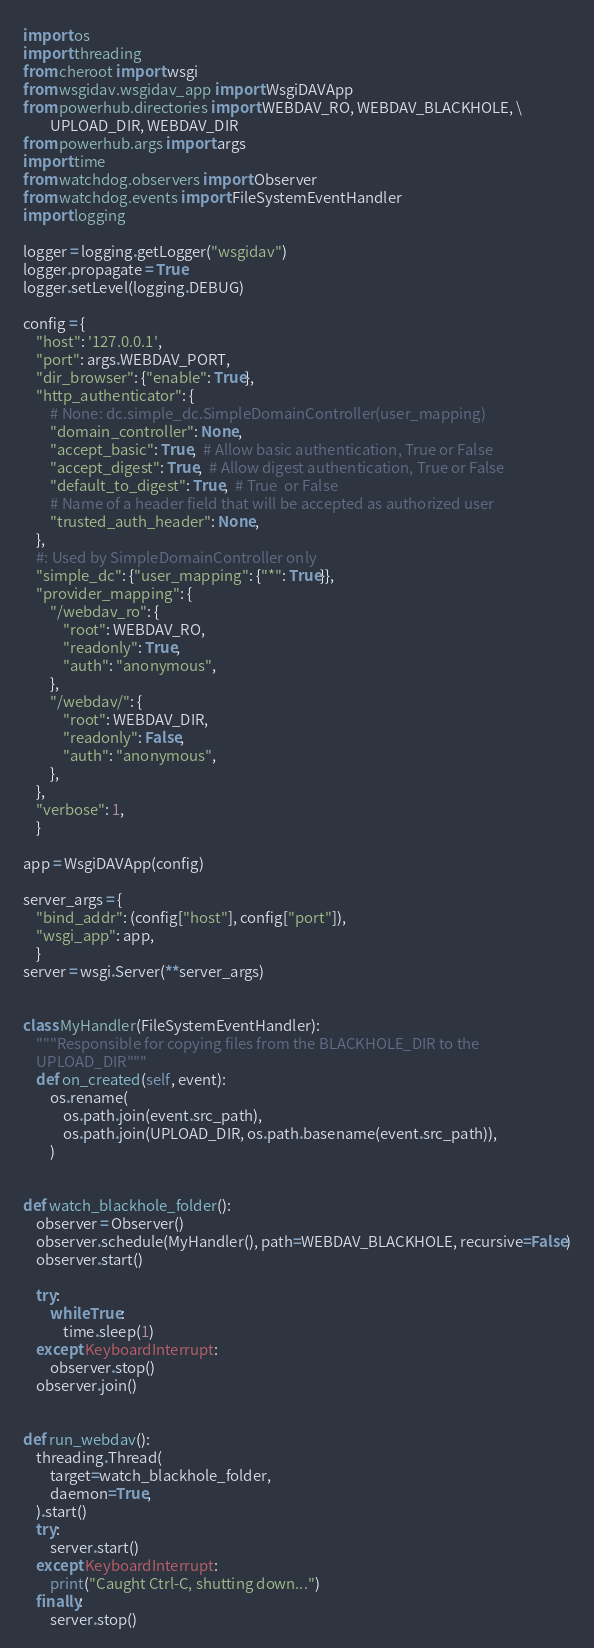Convert code to text. <code><loc_0><loc_0><loc_500><loc_500><_Python_>import os
import threading
from cheroot import wsgi
from wsgidav.wsgidav_app import WsgiDAVApp
from powerhub.directories import WEBDAV_RO, WEBDAV_BLACKHOLE, \
        UPLOAD_DIR, WEBDAV_DIR
from powerhub.args import args
import time
from watchdog.observers import Observer
from watchdog.events import FileSystemEventHandler
import logging

logger = logging.getLogger("wsgidav")
logger.propagate = True
logger.setLevel(logging.DEBUG)

config = {
    "host": '127.0.0.1',
    "port": args.WEBDAV_PORT,
    "dir_browser": {"enable": True},
    "http_authenticator": {
        # None: dc.simple_dc.SimpleDomainController(user_mapping)
        "domain_controller": None,
        "accept_basic": True,  # Allow basic authentication, True or False
        "accept_digest": True,  # Allow digest authentication, True or False
        "default_to_digest": True,  # True  or False
        # Name of a header field that will be accepted as authorized user
        "trusted_auth_header": None,
    },
    #: Used by SimpleDomainController only
    "simple_dc": {"user_mapping": {"*": True}},
    "provider_mapping": {
        "/webdav_ro": {
            "root": WEBDAV_RO,
            "readonly": True,
            "auth": "anonymous",
        },
        "/webdav/": {
            "root": WEBDAV_DIR,
            "readonly": False,
            "auth": "anonymous",
        },
    },
    "verbose": 1,
    }

app = WsgiDAVApp(config)

server_args = {
    "bind_addr": (config["host"], config["port"]),
    "wsgi_app": app,
    }
server = wsgi.Server(**server_args)


class MyHandler(FileSystemEventHandler):
    """Responsible for copying files from the BLACKHOLE_DIR to the
    UPLOAD_DIR"""
    def on_created(self, event):
        os.rename(
            os.path.join(event.src_path),
            os.path.join(UPLOAD_DIR, os.path.basename(event.src_path)),
        )


def watch_blackhole_folder():
    observer = Observer()
    observer.schedule(MyHandler(), path=WEBDAV_BLACKHOLE, recursive=False)
    observer.start()

    try:
        while True:
            time.sleep(1)
    except KeyboardInterrupt:
        observer.stop()
    observer.join()


def run_webdav():
    threading.Thread(
        target=watch_blackhole_folder,
        daemon=True,
    ).start()
    try:
        server.start()
    except KeyboardInterrupt:
        print("Caught Ctrl-C, shutting down...")
    finally:
        server.stop()
</code> 